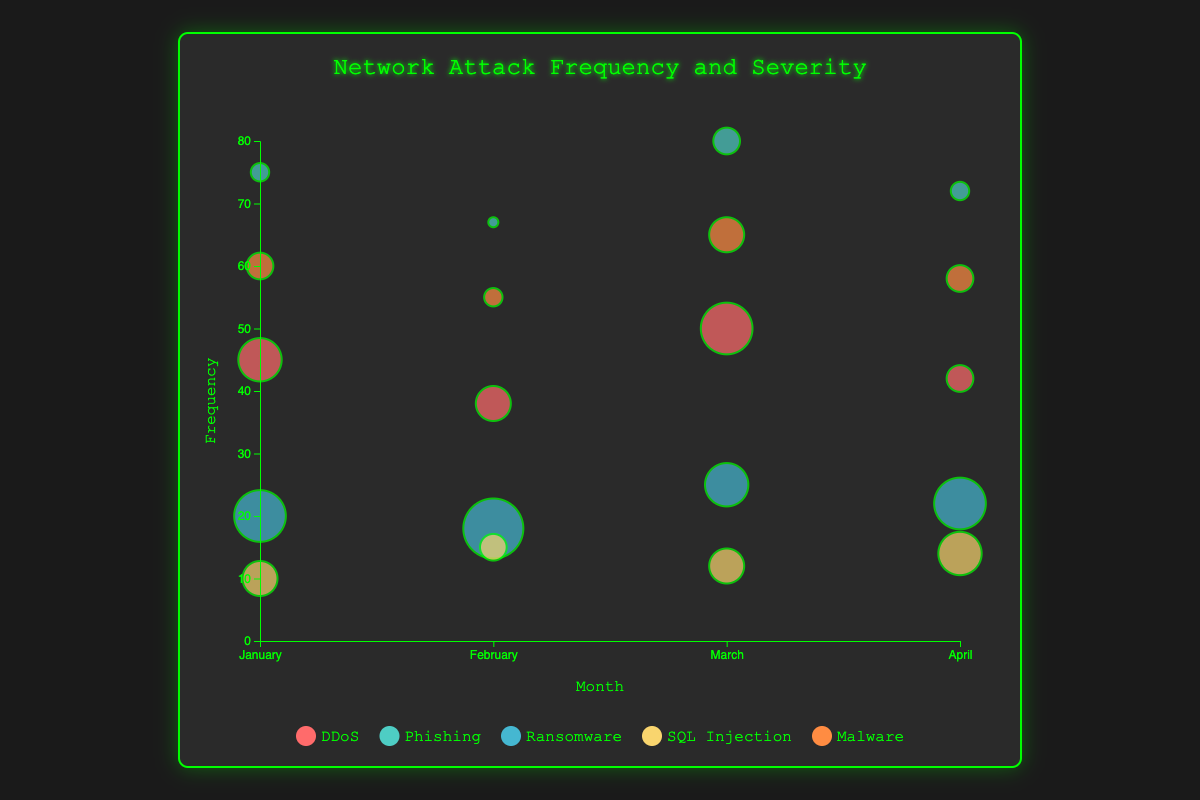What is the title of the chart? The title of the chart is displayed prominently at the top of the chart container. It reads "Network Attack Frequency and Severity."
Answer: Network Attack Frequency and Severity Which month has the highest frequency of Phishing attacks? Observing the data points colored specifically for Phishing, the largest circles are found in March with a frequency value of 80.
Answer: March What is the average severity of DDoS attacks over the months shown? Add the severity values for DDoS in January (8), February (7), March (9), and April (6). Then divide by the number of months: (8 + 7 + 9 + 6) / 4 = 30 / 4 = 7.5.
Answer: 7.5 Which attack type has the lowest frequency in January? Look for the smallest circle within January data points. SQL Injection has a frequency of 10, which is the lowest among the attack types in January.
Answer: SQL Injection Compare the frequency and severity of Ransomware attacks in February to those in March. For February: Frequency is 18 and Severity is 10. For March: Frequency is 25 and Severity is 8. Ransomware attacks in March have higher frequency but lower severity compared to February.
Answer: March has higher frequency, lower severity Which attack type has the highest severity overall, and during which month does it occur? From the data, Ransomware in February has the highest severity with a value of 10.
Answer: Ransomware in February What is the total frequency of Malware attacks over all the months? Summing up the frequency of Malware attacks from January (60), February (55), March (65), and April (58) gives: 60 + 55 + 65 + 58 = 238.
Answer: 238 Which attack type shows the most variability in frequency over the months? Comparing all attack types, Phishing shows significant variability with frequencies of 75, 67, 80, and 72.
Answer: Phishing How does the average frequency of SQL Injection attacks compare to that of Malware attacks? Calculate the average frequency for each:
SQL Injection: (10 + 15 + 12 + 14) / 4 = 51 / 4 = 12.75.
Malware: (60 + 55 + 65 + 58) / 4 = 238 / 4 = 59.5.
Malware attacks have a significantly higher average frequency.
Answer: Malware attacks have a higher average frequency What can be inferred about the relationship between frequency and severity for the different attack types? By examining the bubble sizes and placements, one can see that higher frequencies do not always correspond to higher severities. For instance, Phishing has high frequencies but relatively lower severities, while Ransomware often has lower frequencies but higher severities.
Answer: Frequency and severity are not directly correlated 